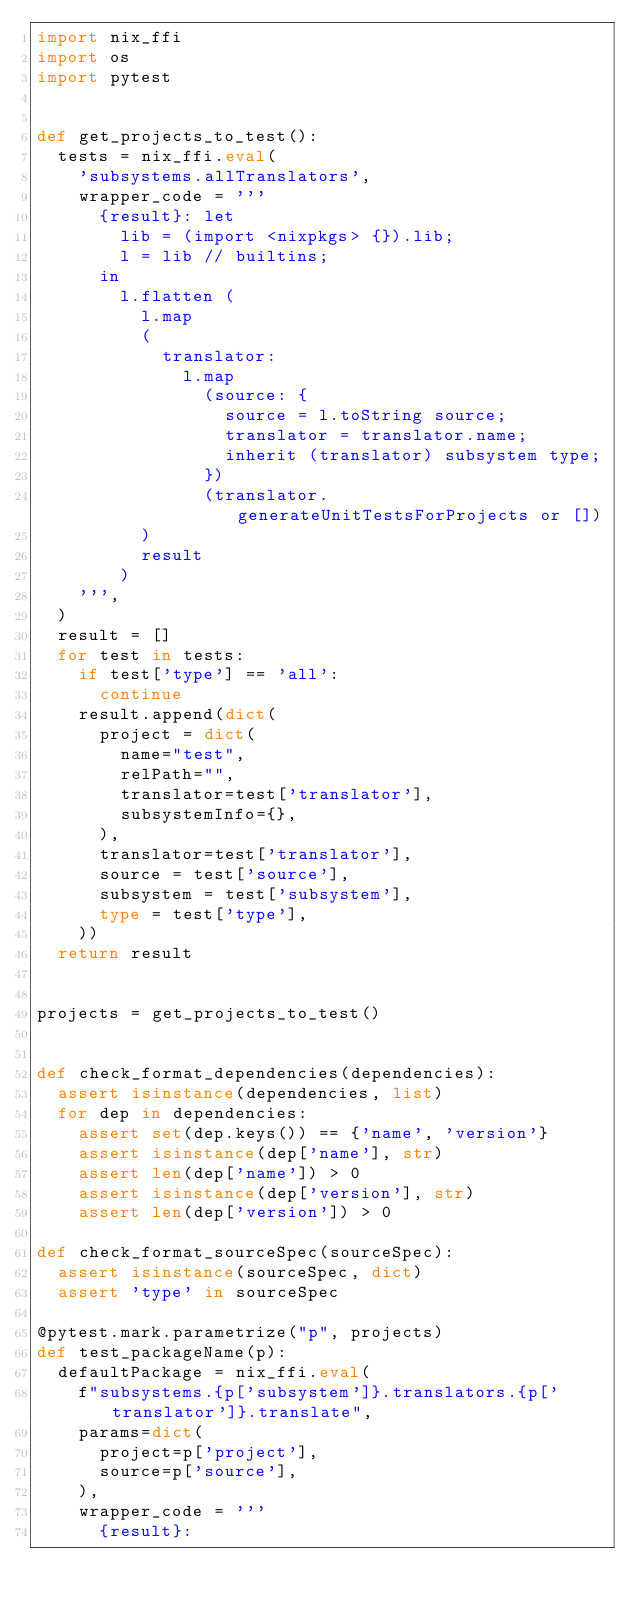Convert code to text. <code><loc_0><loc_0><loc_500><loc_500><_Python_>import nix_ffi
import os
import pytest


def get_projects_to_test():
  tests = nix_ffi.eval(
    'subsystems.allTranslators',
    wrapper_code = '''
      {result}: let
        lib = (import <nixpkgs> {}).lib;
        l = lib // builtins;
      in
        l.flatten (
          l.map
          (
            translator:
              l.map
                (source: {
                  source = l.toString source;
                  translator = translator.name;
                  inherit (translator) subsystem type;
                })
                (translator.generateUnitTestsForProjects or [])
          )
          result
        )
    ''',
  )
  result = []
  for test in tests:
    if test['type'] == 'all':
      continue
    result.append(dict(
      project = dict(
        name="test",
        relPath="",
        translator=test['translator'],
        subsystemInfo={},
      ),
      translator=test['translator'],
      source = test['source'],
      subsystem = test['subsystem'],
      type = test['type'],
    ))
  return result


projects = get_projects_to_test()


def check_format_dependencies(dependencies):
  assert isinstance(dependencies, list)
  for dep in dependencies:
    assert set(dep.keys()) == {'name', 'version'}
    assert isinstance(dep['name'], str)
    assert len(dep['name']) > 0
    assert isinstance(dep['version'], str)
    assert len(dep['version']) > 0

def check_format_sourceSpec(sourceSpec):
  assert isinstance(sourceSpec, dict)
  assert 'type' in sourceSpec

@pytest.mark.parametrize("p", projects)
def test_packageName(p):
  defaultPackage = nix_ffi.eval(
    f"subsystems.{p['subsystem']}.translators.{p['translator']}.translate",
    params=dict(
      project=p['project'],
      source=p['source'],
    ),
    wrapper_code = '''
      {result}:</code> 